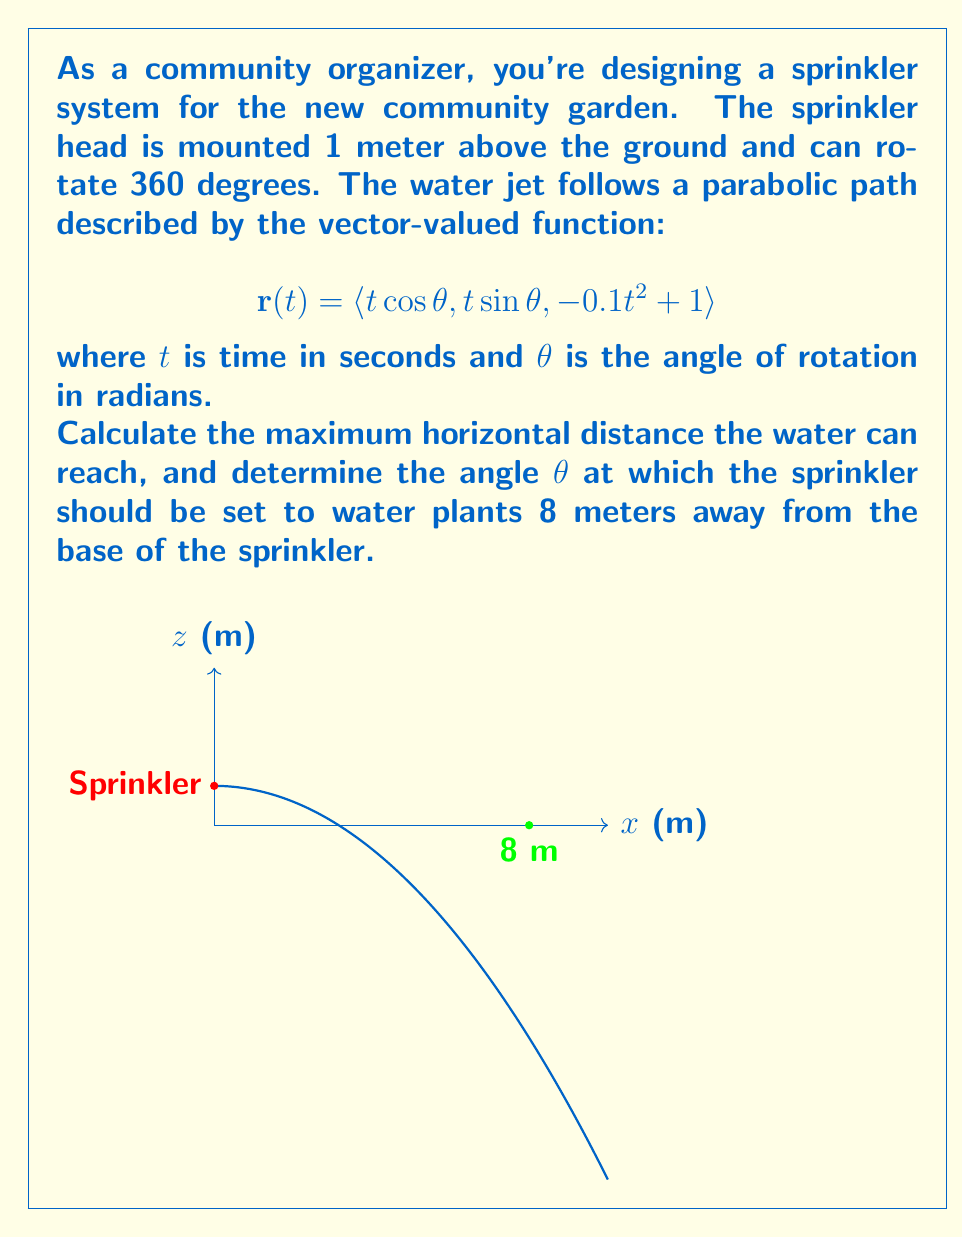What is the answer to this math problem? Let's approach this problem step by step:

1) First, we need to find when the water hits the ground. This occurs when z = 0:
   $$-0.1t^2 + 1 = 0$$
   $$t^2 = 10$$
   $$t = \sqrt{10} \approx 3.16 \text{ seconds}$$

2) The horizontal distance traveled is given by $\sqrt{(t\cos\theta)^2 + (t\sin\theta)^2} = t$. 
   So the maximum horizontal distance is $\sqrt{10} \approx 3.16 \text{ meters}$.

3) To water plants 8 meters away, we need to adjust the angle $\theta$. The horizontal distance is still given by $t$, but now we know it should be 8 meters.

4) Substituting into the z-component of our vector function:
   $$0 = -0.1(8^2) + 1$$
   $$0 = -6.4 + 1 = -5.4$$

5) This is not possible with our current function, as the water can't reach 8 meters horizontally.

6) To find the angle that reaches the farthest, we can use the projectile motion formula:
   $$R = \frac{v^2\sin(2\theta)}{g}$$
   where $R$ is the range, $v$ is the initial velocity, and $g$ is gravity (9.8 m/s^2).

7) The maximum range occurs when $\sin(2\theta) = 1$, which happens when $2\theta = 90°$ or $\theta = 45°$.

8) We can find the initial velocity by using the maximum distance we calculated earlier:
   $$3.16 = \frac{v^2\sin(90°)}{9.8}$$
   $$v = \sqrt{3.16 * 9.8} \approx 5.57 \text{ m/s}$$
Answer: Maximum distance: 3.16 m. Angle for 8 m: Not possible. Optimal angle: 45°. 